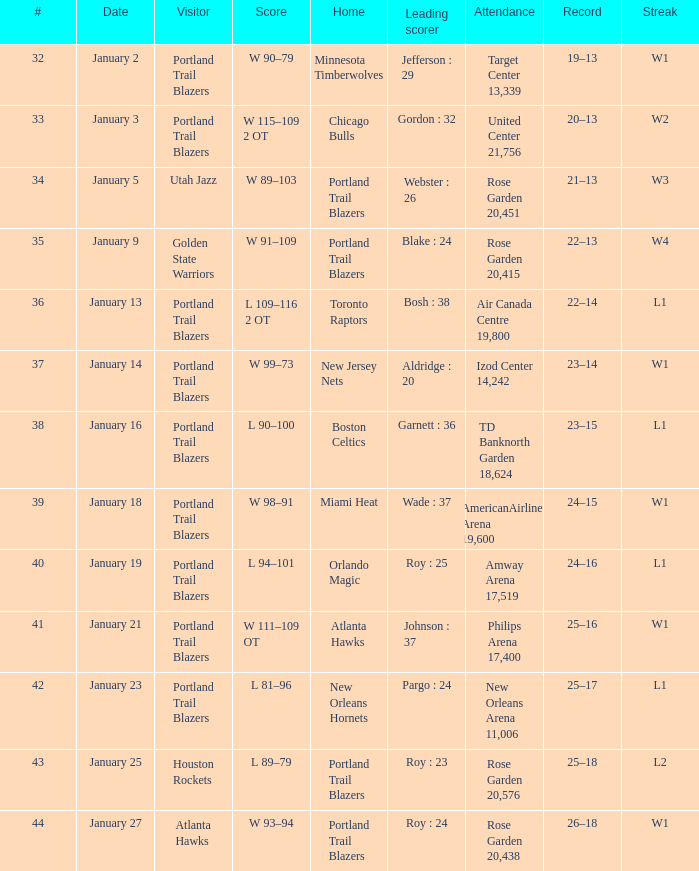Which visitors have a leading scorer of roy : 25 Portland Trail Blazers. 